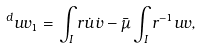Convert formula to latex. <formula><loc_0><loc_0><loc_500><loc_500>^ { d } u v _ { 1 } = \int _ { I } r \dot { u } \dot { v } - \bar { \mu } \int _ { I } r ^ { - 1 } u v ,</formula> 